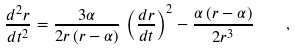Convert formula to latex. <formula><loc_0><loc_0><loc_500><loc_500>\frac { d ^ { 2 } r } { d t ^ { 2 } } = \frac { 3 \alpha } { 2 r \, ( r - \alpha ) } \, \left ( \frac { d r } { d t } \right ) ^ { 2 } - \frac { \alpha \, ( r - \alpha ) } { 2 r ^ { 3 } } \quad ,</formula> 